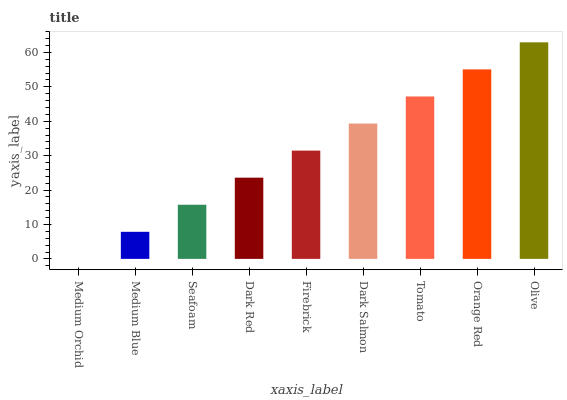Is Medium Orchid the minimum?
Answer yes or no. Yes. Is Olive the maximum?
Answer yes or no. Yes. Is Medium Blue the minimum?
Answer yes or no. No. Is Medium Blue the maximum?
Answer yes or no. No. Is Medium Blue greater than Medium Orchid?
Answer yes or no. Yes. Is Medium Orchid less than Medium Blue?
Answer yes or no. Yes. Is Medium Orchid greater than Medium Blue?
Answer yes or no. No. Is Medium Blue less than Medium Orchid?
Answer yes or no. No. Is Firebrick the high median?
Answer yes or no. Yes. Is Firebrick the low median?
Answer yes or no. Yes. Is Olive the high median?
Answer yes or no. No. Is Medium Blue the low median?
Answer yes or no. No. 